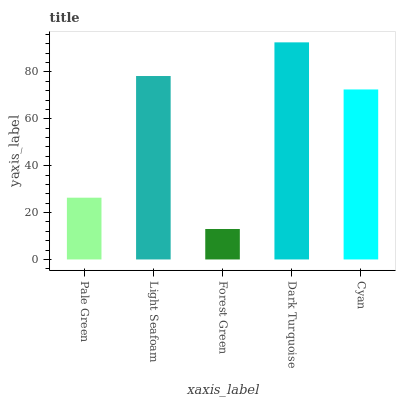Is Forest Green the minimum?
Answer yes or no. Yes. Is Dark Turquoise the maximum?
Answer yes or no. Yes. Is Light Seafoam the minimum?
Answer yes or no. No. Is Light Seafoam the maximum?
Answer yes or no. No. Is Light Seafoam greater than Pale Green?
Answer yes or no. Yes. Is Pale Green less than Light Seafoam?
Answer yes or no. Yes. Is Pale Green greater than Light Seafoam?
Answer yes or no. No. Is Light Seafoam less than Pale Green?
Answer yes or no. No. Is Cyan the high median?
Answer yes or no. Yes. Is Cyan the low median?
Answer yes or no. Yes. Is Light Seafoam the high median?
Answer yes or no. No. Is Pale Green the low median?
Answer yes or no. No. 